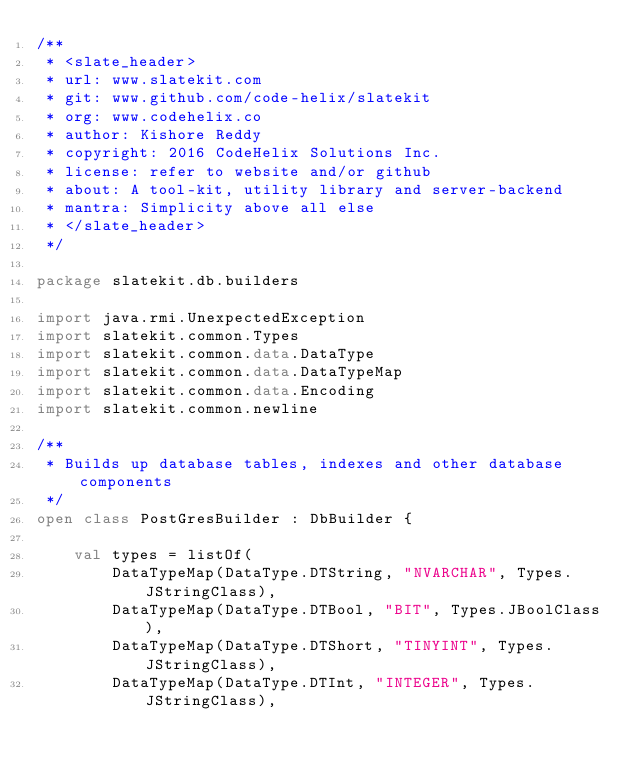Convert code to text. <code><loc_0><loc_0><loc_500><loc_500><_Kotlin_>/**
 * <slate_header>
 * url: www.slatekit.com
 * git: www.github.com/code-helix/slatekit
 * org: www.codehelix.co
 * author: Kishore Reddy
 * copyright: 2016 CodeHelix Solutions Inc.
 * license: refer to website and/or github
 * about: A tool-kit, utility library and server-backend
 * mantra: Simplicity above all else
 * </slate_header>
 */

package slatekit.db.builders

import java.rmi.UnexpectedException
import slatekit.common.Types
import slatekit.common.data.DataType
import slatekit.common.data.DataTypeMap
import slatekit.common.data.Encoding
import slatekit.common.newline

/**
 * Builds up database tables, indexes and other database components
 */
open class PostGresBuilder : DbBuilder {

    val types = listOf(
        DataTypeMap(DataType.DTString, "NVARCHAR", Types.JStringClass),
        DataTypeMap(DataType.DTBool, "BIT", Types.JBoolClass),
        DataTypeMap(DataType.DTShort, "TINYINT", Types.JStringClass),
        DataTypeMap(DataType.DTInt, "INTEGER", Types.JStringClass),</code> 